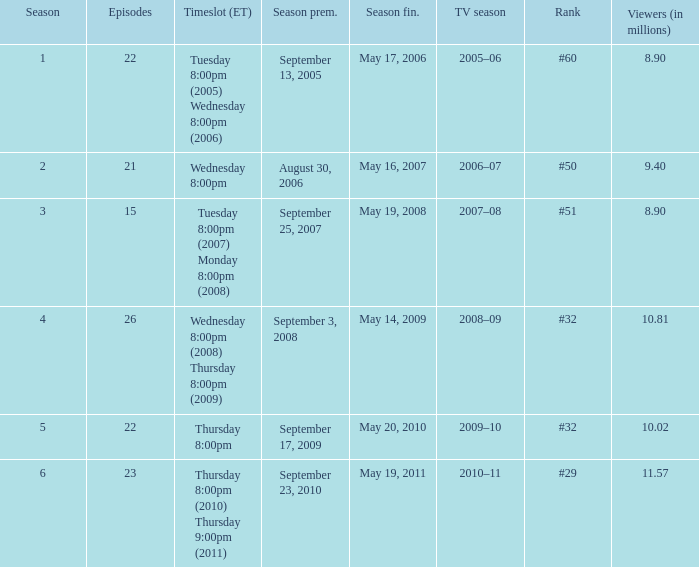When did the season finale reached an audience of 10.02 million viewers? May 20, 2010. 